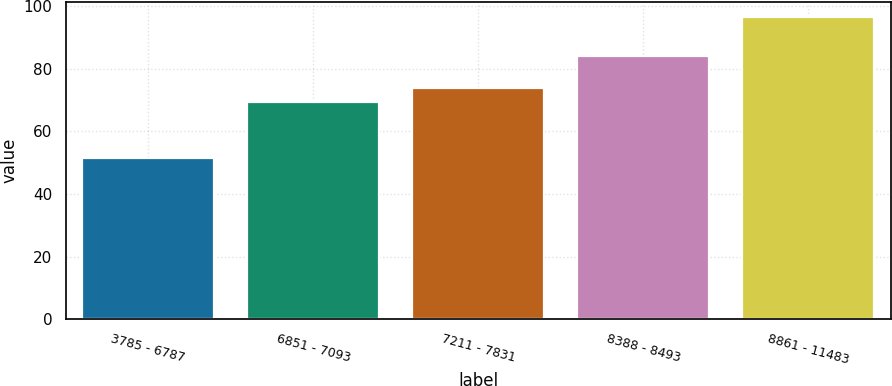Convert chart to OTSL. <chart><loc_0><loc_0><loc_500><loc_500><bar_chart><fcel>3785 - 6787<fcel>6851 - 7093<fcel>7211 - 7831<fcel>8388 - 8493<fcel>8861 - 11483<nl><fcel>51.53<fcel>69.26<fcel>73.76<fcel>84.21<fcel>96.55<nl></chart> 